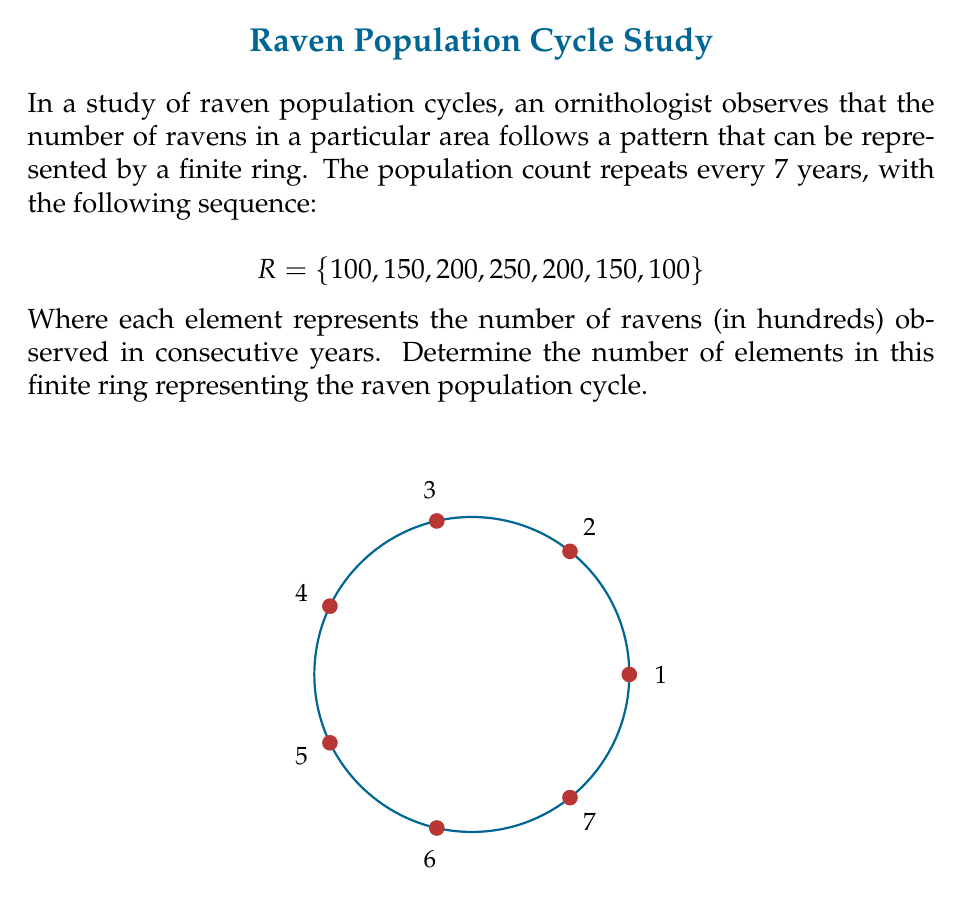Solve this math problem. To determine the number of elements in this finite ring, we need to understand the properties of the given set $R$ and how it relates to ring theory:

1) In ring theory, a finite ring is a ring with a finite number of elements.

2) The given set $R = \{100, 150, 200, 250, 200, 150, 100\}$ represents a cycle of raven population counts that repeats every 7 years.

3) In this context, each element of the set represents a distinct state of the population, corresponding to a year in the cycle.

4) The number of elements in the ring is equal to the number of distinct states in the cycle.

5) Counting the elements in the set $R$, we find:
   - 100 appears twice, but represents the same state (start/end of cycle)
   - 150 appears twice
   - 200 appears twice
   - 250 appears once

6) Therefore, there are 7 distinct elements in the set, corresponding to the 7 years in the cycle.

7) This aligns with the properties of a finite ring, where the number of elements is finite and the operations (in this case, progression through years) eventually return to the starting point.

Thus, the number of elements in this finite ring representing the raven population cycle is 7.
Answer: 7 